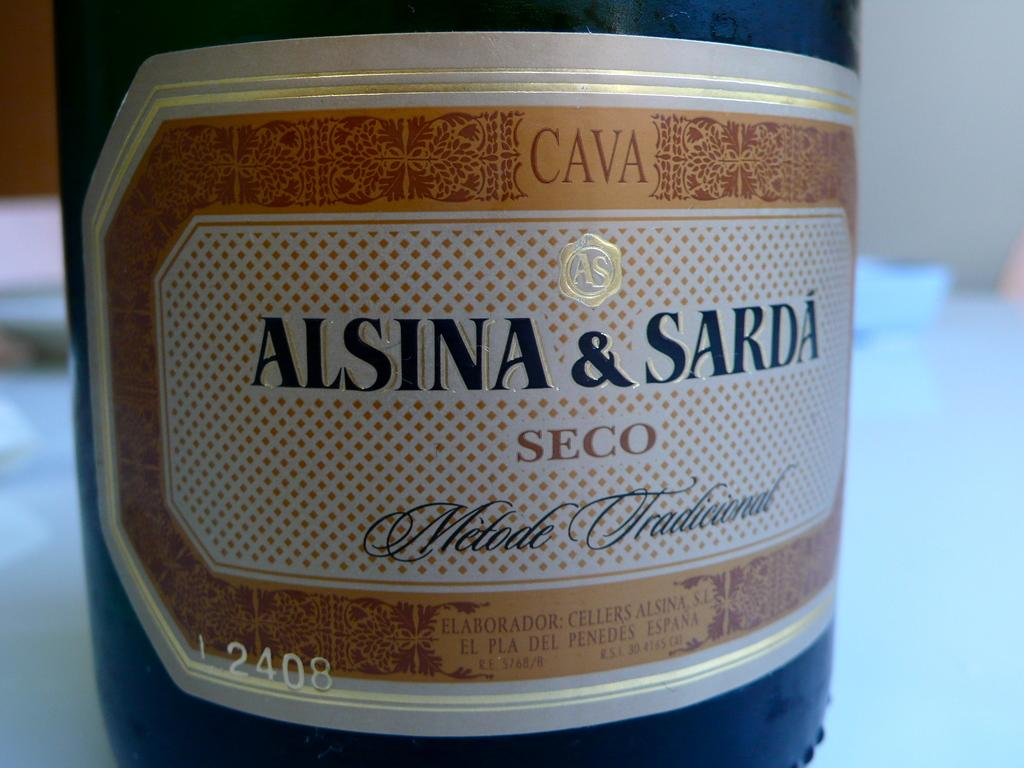Provide a one-sentence caption for the provided image. A bottle that reads "Alsina & Sarda" seco. 